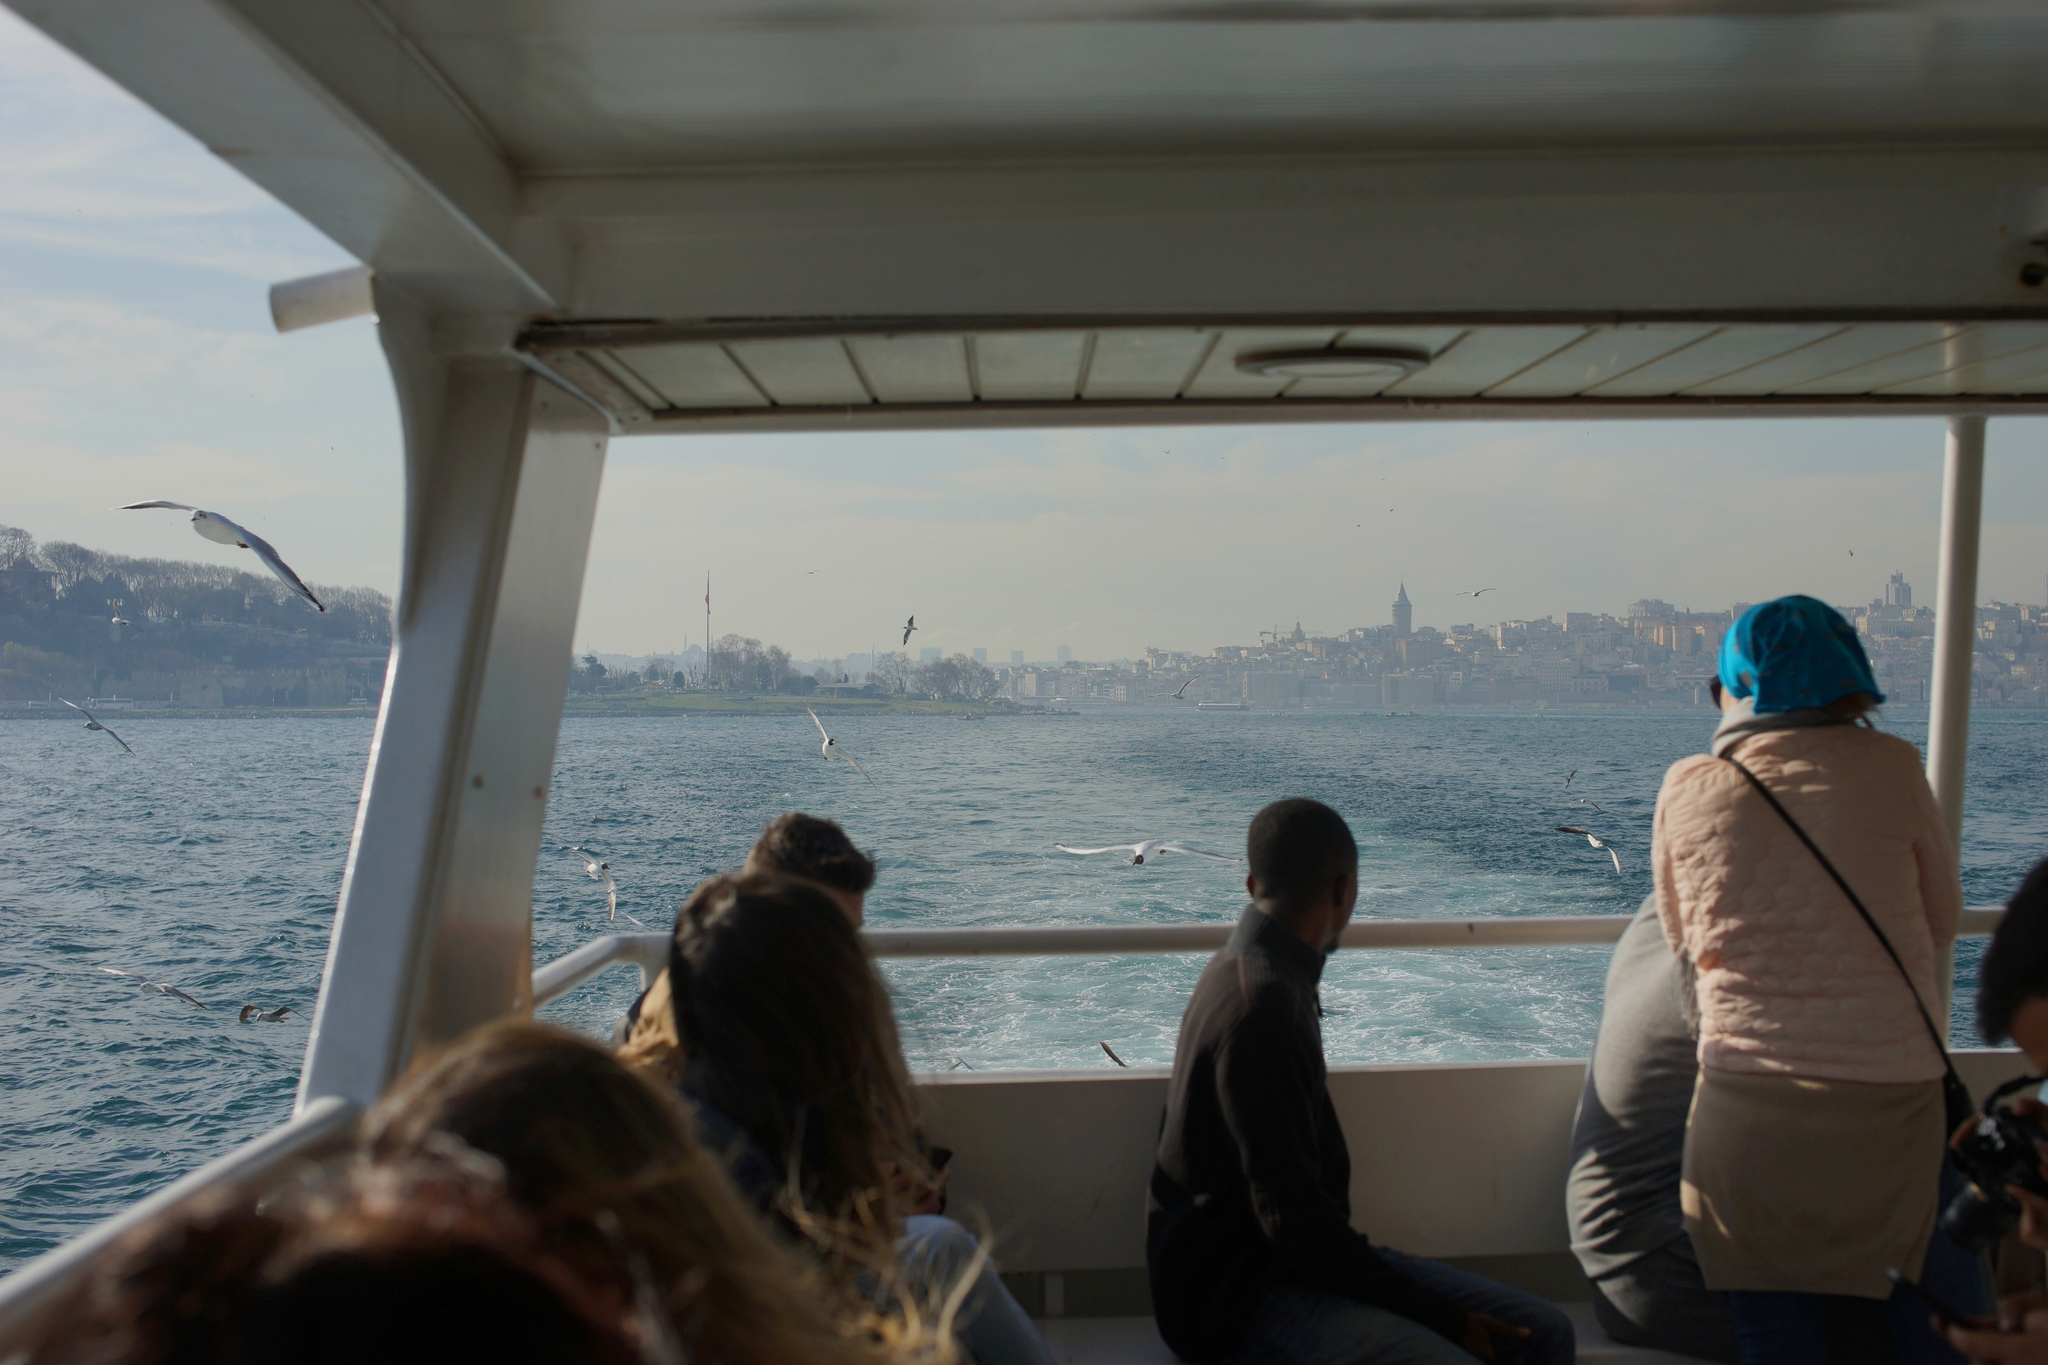What is a possible everyday scenario taking place here? In this everyday scenario, a group of tourists is enjoying a mid-morning boat tour along the city's waterfront. They've set off under a clear sky, with the gentle breeze adding a refreshing touch to their journey. As the boat glides through the serene waters, passengers are engaged in light conversations, snapping photos of the impressive skyline and the playful seagulls. A tour guide might be sharing intriguing facts about the city's historical landmarks, pointing out key buildings and recounting stories of the past. The tourists are immersed in the experience, combining relaxation with exploration, creating lasting memories of their trip. 